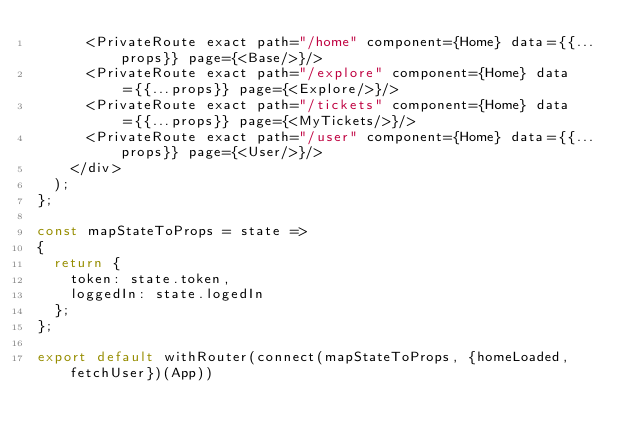<code> <loc_0><loc_0><loc_500><loc_500><_JavaScript_>      <PrivateRoute exact path="/home" component={Home} data={{...props}} page={<Base/>}/>
      <PrivateRoute exact path="/explore" component={Home} data={{...props}} page={<Explore/>}/>
      <PrivateRoute exact path="/tickets" component={Home} data={{...props}} page={<MyTickets/>}/>
      <PrivateRoute exact path="/user" component={Home} data={{...props}} page={<User/>}/>
    </div>
  );
};

const mapStateToProps = state => 
{
  return {
    token: state.token,
    loggedIn: state.logedIn
  };
};

export default withRouter(connect(mapStateToProps, {homeLoaded, fetchUser})(App))</code> 